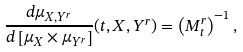Convert formula to latex. <formula><loc_0><loc_0><loc_500><loc_500>\frac { d \mu _ { X , Y ^ { r } } } { d \left [ \mu _ { X } \times \mu _ { Y ^ { r } } \right ] } ( t , X , Y ^ { r } ) = \left ( M _ { t } ^ { r } \right ) ^ { - 1 } ,</formula> 